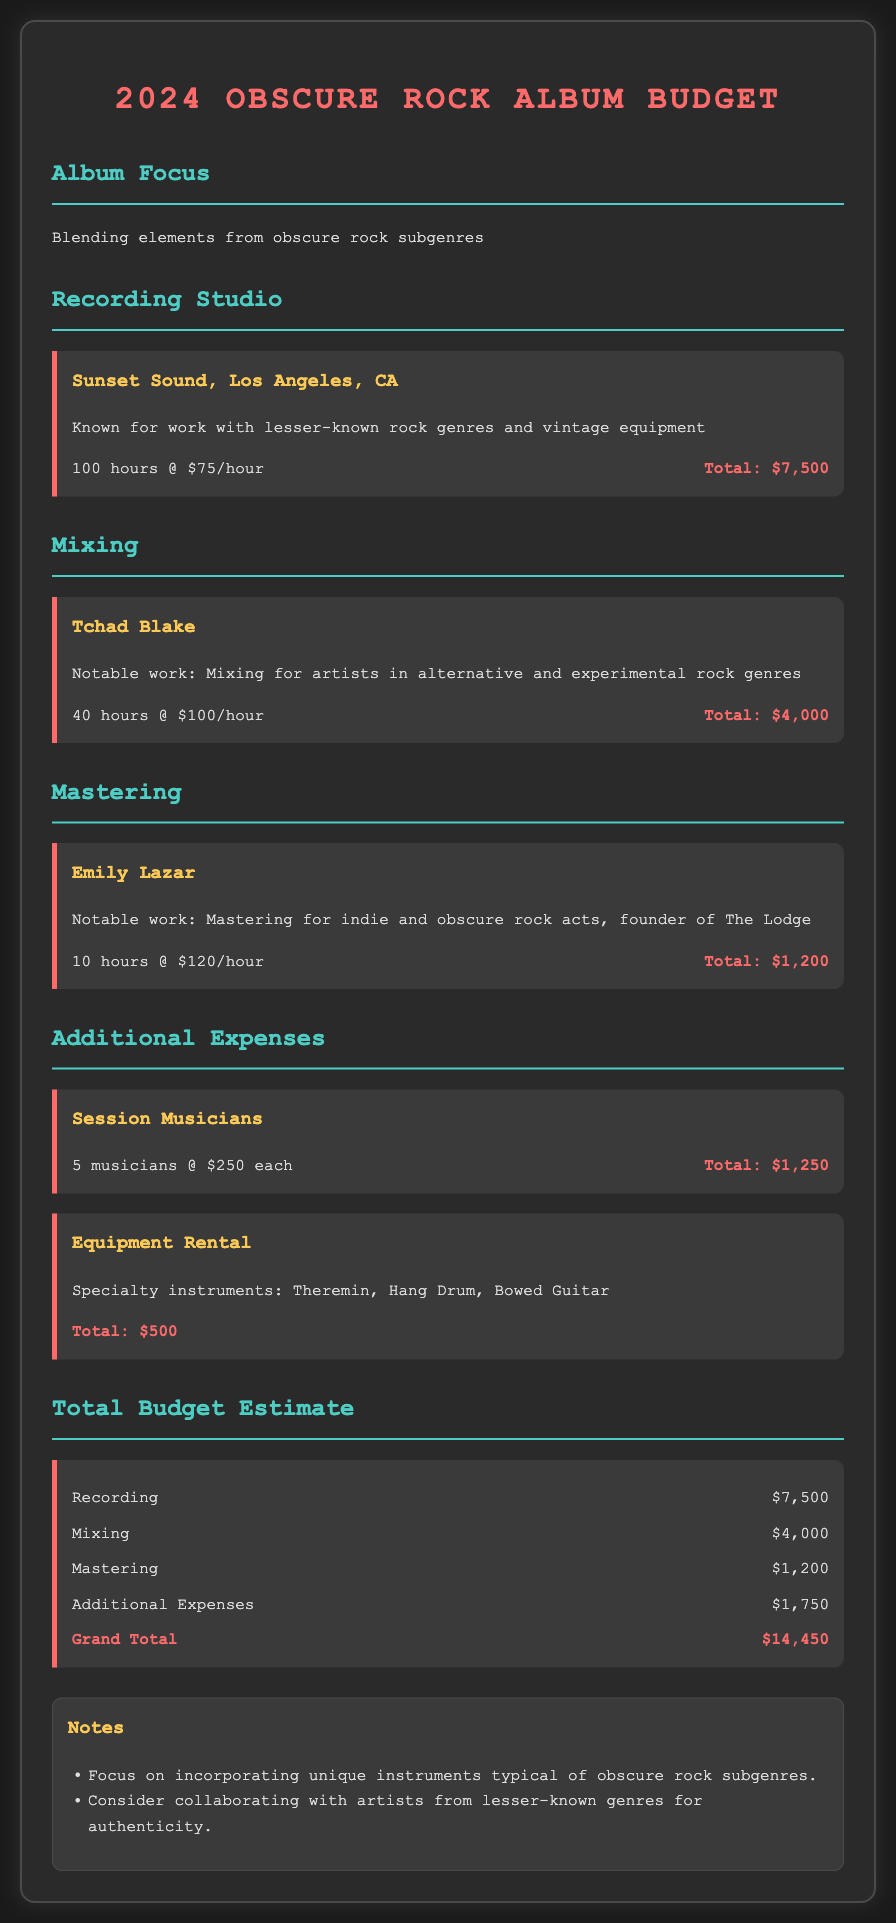what is the total budget estimate? The total budget estimate is the grand total calculated from all expenses listed in the document.
Answer: $14,450 how many hours of recording studio time is budgeted? The document states that 100 hours are allocated for recording studio time at Sunset Sound.
Answer: 100 hours who is responsible for mixing the album? Tchad Blake is identified in the document as the individual responsible for mixing the album.
Answer: Tchad Blake what is the hourly rate for mastering? The document specifies the hourly rate for mastering services performed by Emily Lazar.
Answer: $120/hour what is the total cost for session musicians? The document outlines that 5 session musicians are hired at a specific cost each, leading to a total cost for this line item.
Answer: $1,250 how many additional expenses categories are listed? To understand the range of costs covered, we can count the individual additional expenses listed.
Answer: 2 categories what type of instruments are included in the equipment rental? The document lists a few specialty instruments that will be rented for the album production.
Answer: Theremin, Hang Drum, Bowed Guitar how much is budgeted for mixing? The document details the cost allocated specifically for the mixing phase of the album.
Answer: $4,000 who is handling the mastering of the album? The document names the professional contracted for mastering services for the album.
Answer: Emily Lazar 